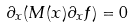<formula> <loc_0><loc_0><loc_500><loc_500>\partial _ { x } ( M ( x ) \partial _ { x } f ) = 0</formula> 